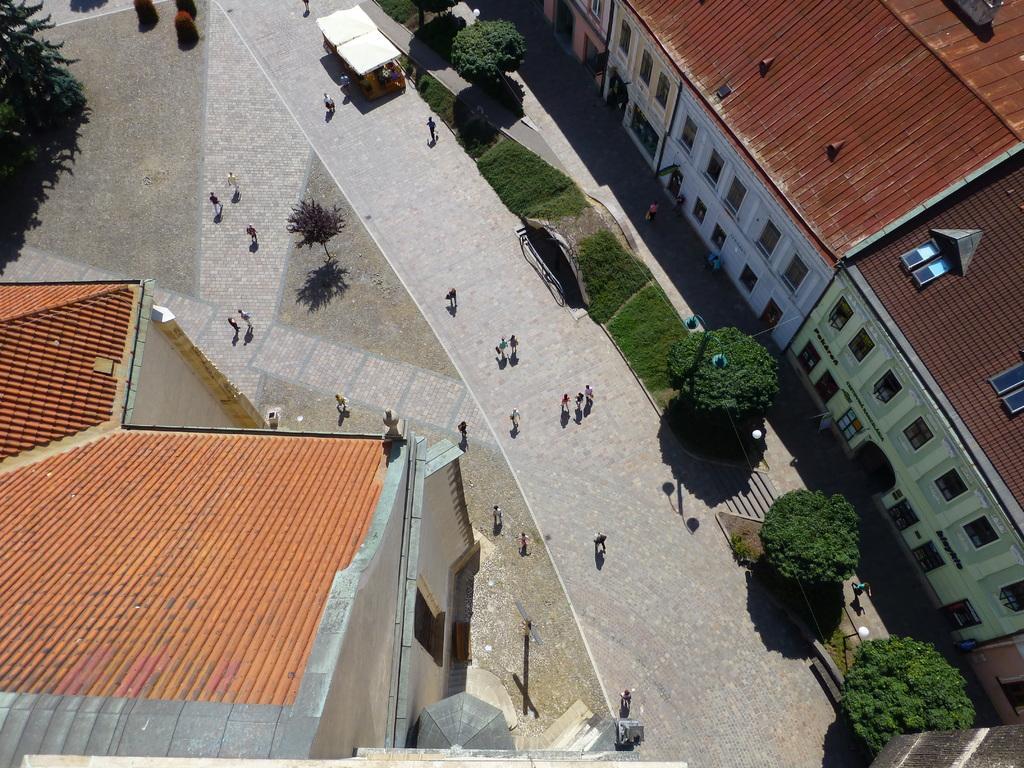Please provide a concise description of this image. In this picture I can see few persons in the middle, there are trees and buildings on either side of this image. 